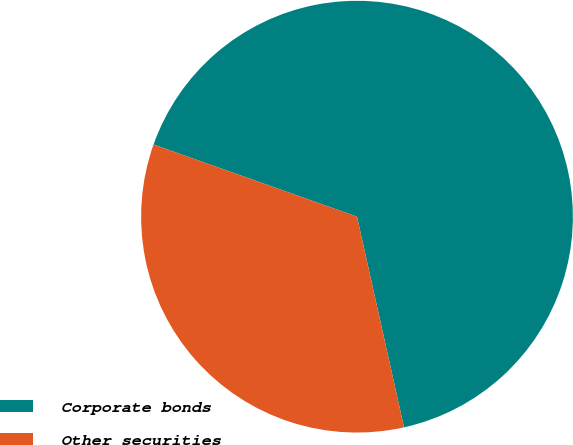<chart> <loc_0><loc_0><loc_500><loc_500><pie_chart><fcel>Corporate bonds<fcel>Other securities<nl><fcel>66.08%<fcel>33.92%<nl></chart> 